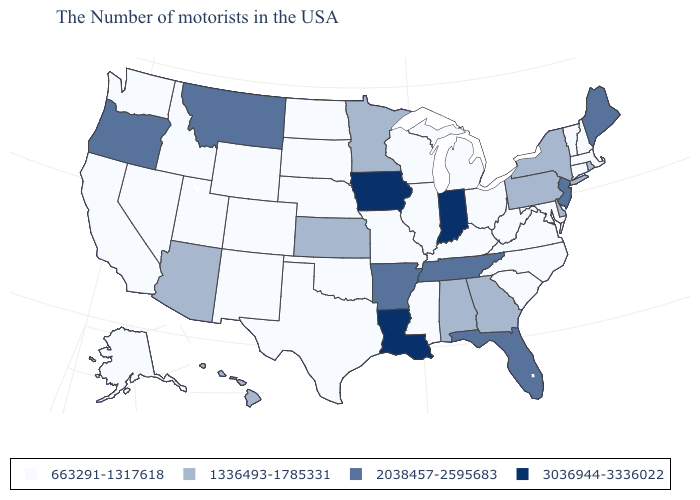Name the states that have a value in the range 1336493-1785331?
Be succinct. Rhode Island, New York, Delaware, Pennsylvania, Georgia, Alabama, Minnesota, Kansas, Arizona, Hawaii. Name the states that have a value in the range 663291-1317618?
Short answer required. Massachusetts, New Hampshire, Vermont, Connecticut, Maryland, Virginia, North Carolina, South Carolina, West Virginia, Ohio, Michigan, Kentucky, Wisconsin, Illinois, Mississippi, Missouri, Nebraska, Oklahoma, Texas, South Dakota, North Dakota, Wyoming, Colorado, New Mexico, Utah, Idaho, Nevada, California, Washington, Alaska. What is the value of Oregon?
Write a very short answer. 2038457-2595683. Does California have the lowest value in the USA?
Keep it brief. Yes. What is the value of Michigan?
Keep it brief. 663291-1317618. How many symbols are there in the legend?
Keep it brief. 4. Name the states that have a value in the range 3036944-3336022?
Concise answer only. Indiana, Louisiana, Iowa. What is the value of Hawaii?
Be succinct. 1336493-1785331. Name the states that have a value in the range 663291-1317618?
Keep it brief. Massachusetts, New Hampshire, Vermont, Connecticut, Maryland, Virginia, North Carolina, South Carolina, West Virginia, Ohio, Michigan, Kentucky, Wisconsin, Illinois, Mississippi, Missouri, Nebraska, Oklahoma, Texas, South Dakota, North Dakota, Wyoming, Colorado, New Mexico, Utah, Idaho, Nevada, California, Washington, Alaska. Among the states that border Delaware , does Maryland have the highest value?
Be succinct. No. Which states have the lowest value in the MidWest?
Keep it brief. Ohio, Michigan, Wisconsin, Illinois, Missouri, Nebraska, South Dakota, North Dakota. Does the first symbol in the legend represent the smallest category?
Keep it brief. Yes. Among the states that border California , does Oregon have the highest value?
Keep it brief. Yes. Does Louisiana have a higher value than Iowa?
Quick response, please. No. What is the value of New Jersey?
Be succinct. 2038457-2595683. 